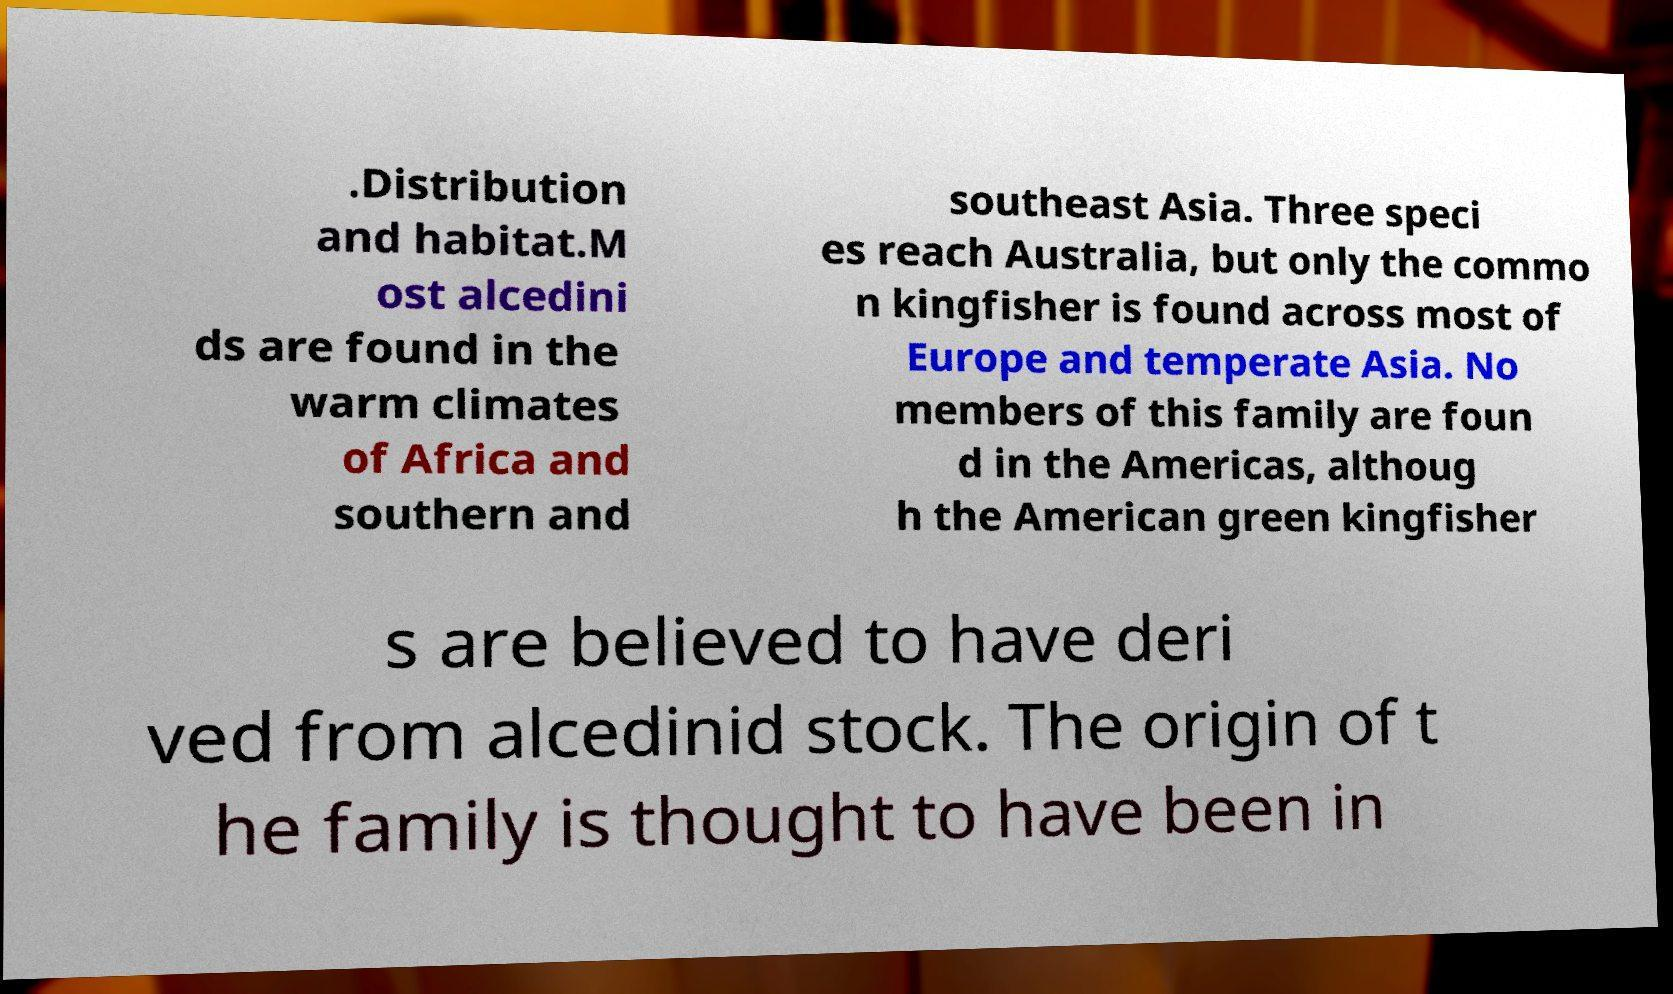I need the written content from this picture converted into text. Can you do that? .Distribution and habitat.M ost alcedini ds are found in the warm climates of Africa and southern and southeast Asia. Three speci es reach Australia, but only the commo n kingfisher is found across most of Europe and temperate Asia. No members of this family are foun d in the Americas, althoug h the American green kingfisher s are believed to have deri ved from alcedinid stock. The origin of t he family is thought to have been in 